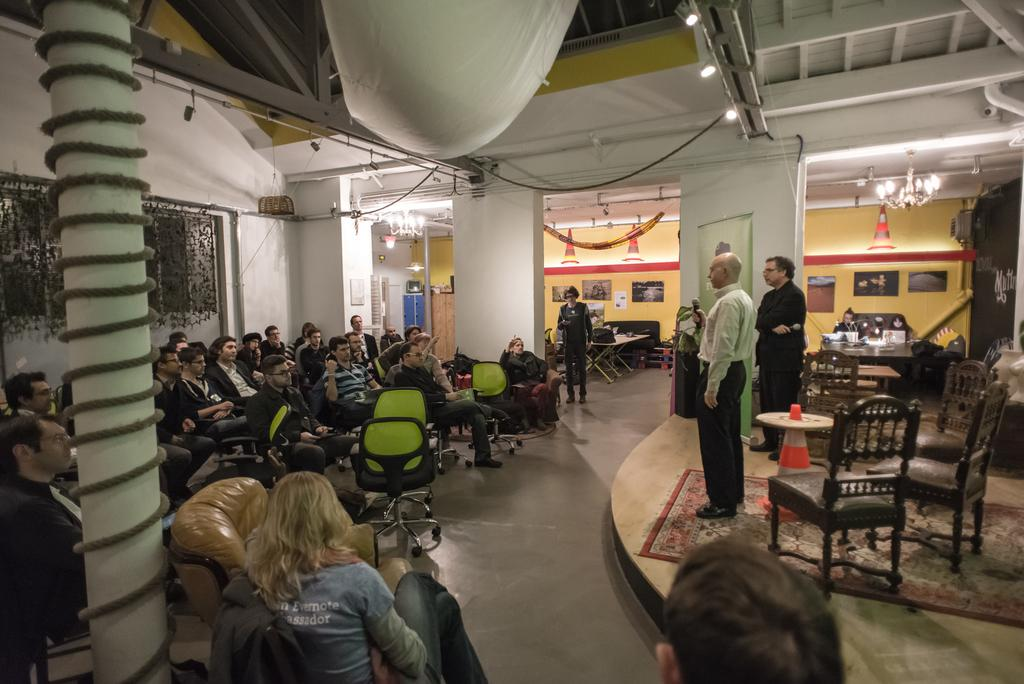What is the man doing on the stage in the image? The man is speaking on the stage. What might the man be holding in his hand? The man is holding something in his hand, but it is not clear what it is from the image. Who is the man addressing on the stage? The man is addressing a group of people who are listening to him. How are the people positioned while listening to the man? The people are sitting in chairs while listening to the man. Can you see a tiger performing magic tricks on the stage in the image? No, there is no tiger or magic tricks present in the image. 